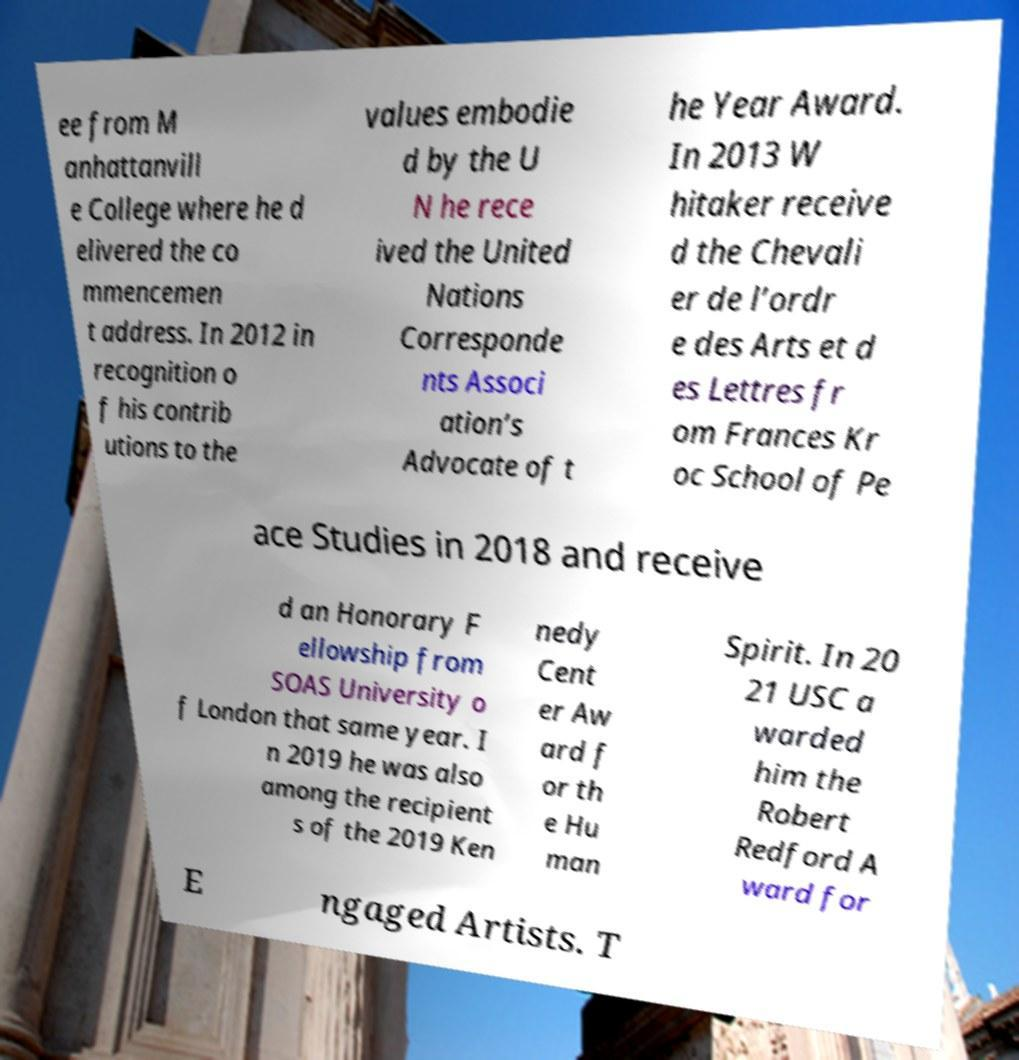Could you assist in decoding the text presented in this image and type it out clearly? ee from M anhattanvill e College where he d elivered the co mmencemen t address. In 2012 in recognition o f his contrib utions to the values embodie d by the U N he rece ived the United Nations Corresponde nts Associ ation’s Advocate of t he Year Award. In 2013 W hitaker receive d the Chevali er de l’ordr e des Arts et d es Lettres fr om Frances Kr oc School of Pe ace Studies in 2018 and receive d an Honorary F ellowship from SOAS University o f London that same year. I n 2019 he was also among the recipient s of the 2019 Ken nedy Cent er Aw ard f or th e Hu man Spirit. In 20 21 USC a warded him the Robert Redford A ward for E ngaged Artists. T 